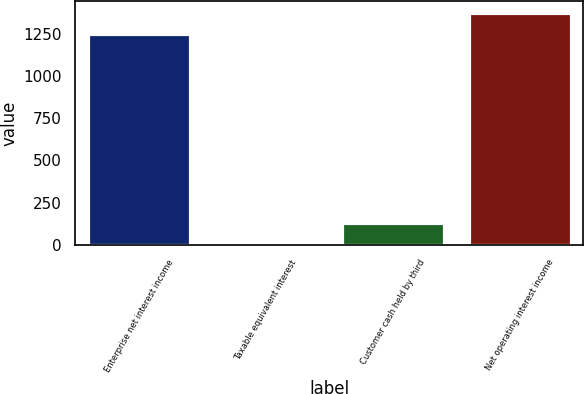Convert chart. <chart><loc_0><loc_0><loc_500><loc_500><bar_chart><fcel>Enterprise net interest income<fcel>Taxable equivalent interest<fcel>Customer cash held by third<fcel>Net operating interest income<nl><fcel>1247.2<fcel>2.1<fcel>127.95<fcel>1373.05<nl></chart> 